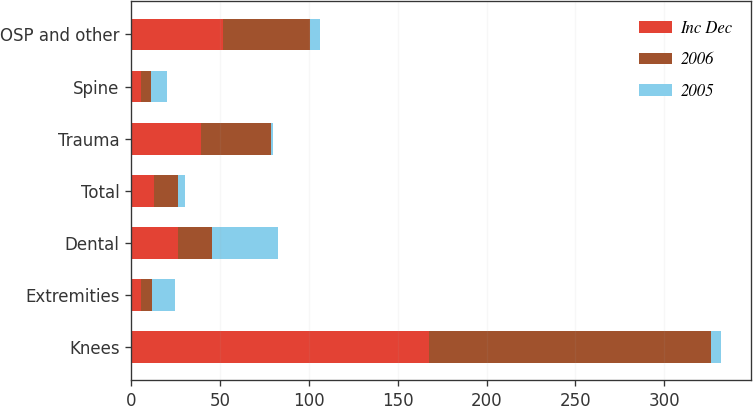<chart> <loc_0><loc_0><loc_500><loc_500><stacked_bar_chart><ecel><fcel>Knees<fcel>Extremities<fcel>Dental<fcel>Total<fcel>Trauma<fcel>Spine<fcel>OSP and other<nl><fcel>Inc Dec<fcel>167.5<fcel>5.5<fcel>26.4<fcel>13<fcel>39.4<fcel>5.7<fcel>51.6<nl><fcel>2006<fcel>158.7<fcel>6.2<fcel>19.2<fcel>13<fcel>39.2<fcel>5.3<fcel>48.7<nl><fcel>2005<fcel>6<fcel>13<fcel>37<fcel>4<fcel>1<fcel>9<fcel>6<nl></chart> 